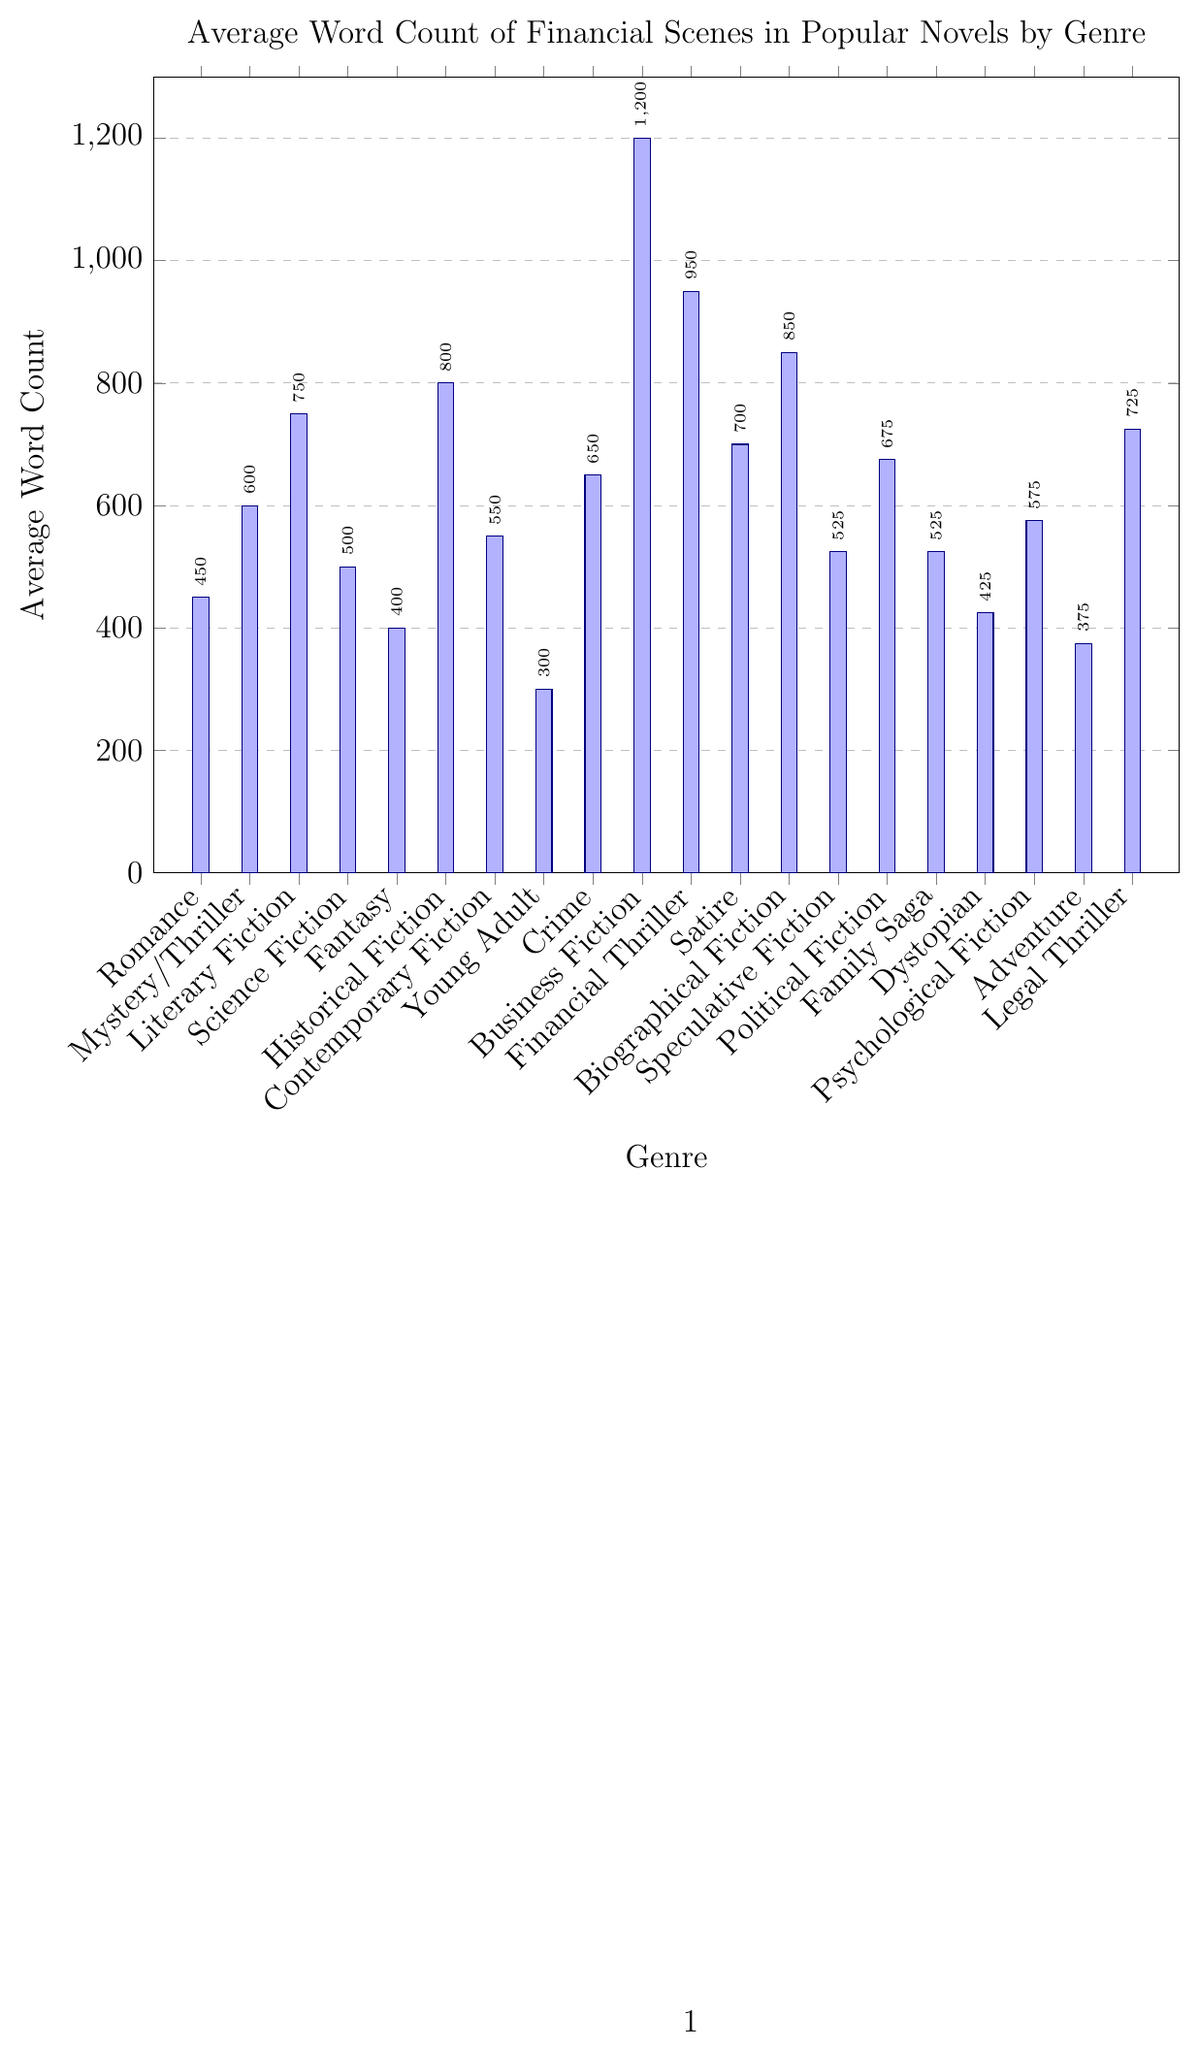What's the genre with the highest average word count for financial scenes? By observing the height of the bars, we can see that the 'Business Fiction' bar is the tallest, indicating it has the highest average word count for financial scenes.
Answer: Business Fiction Which genres have an average word count greater than 700 but less than 900? By comparing bar heights, we can see that 'Financial Thriller', 'Satire', 'Biographical Fiction', 'Political Fiction', and 'Legal Thriller' have average word counts in this range.
Answer: Financial Thriller, Satire, Biographical Fiction, Political Fiction, Legal Thriller How much higher is the average word count for 'Historical Fiction' compared to 'Fantasy'? The average word count for 'Historical Fiction' (800 words) minus 'Fantasy' (400 words) gives the difference. 800 - 400 = 400.
Answer: 400 What is the average word count difference between 'Science Fiction' and 'Family Saga'? 'Science Fiction' has an average word count of 500, and 'Family Saga' has an average word count of 525. The difference is 525 - 500.
Answer: 25 What's the cumulative average word count for all genres starting with the letter 'S'? Sum of average word counts for 'Satire' (700), 'Science Fiction' (500), and 'Speculative Fiction' (525). 700 + 500 + 525 = 1725.
Answer: 1725 Which genre has the smallest average word count for financial scenes? By observing the shortest bar, which corresponds to 'Young Adult', it has the smallest average word count.
Answer: Young Adult How does 'Crime' compare to 'Romance' in terms of the average word count for financial scenes? The average word count for 'Crime' (650) compared to 'Romance' (450). 650 is greater than 450.
Answer: Crime is higher What is the average word count for 'Literary Fiction' and 'Mystery/Thriller' combined? Sum the average word counts for both genres and then divide by 2: (750 + 600) / 2 = 675.
Answer: 675 Which genres have a similar average word count, and what are those counts? 'Science Fiction' and 'Psychological Fiction' both have an average word count of around 500-575, where 'Science Fiction' has 500 and 'Psychological Fiction' has 575. 'Family Saga' and 'Speculative Fiction' both have 525.
Answer: Science Fiction, Psychological Fiction; Family Saga, Speculative Fiction What is the average word count difference between 'Young Adult' and 'Dystopian'? The average word count for 'Young Adult' is 300 and for 'Dystopian' is 425. 425 - 300 = 125.
Answer: 125 What is the median value of the average word count for all genres? First, list out the word counts in ascending order: 300, 375, 400, 425, 450, 500, 525, 525, 550, 575, 600, 650, 675, 700, 725, 750, 800, 850, 950, 1200. Since there are 20 values, the median will be the average of the 10th and 11th values: (575 + 600) / 2 = 587.5.
Answer: 587.5 